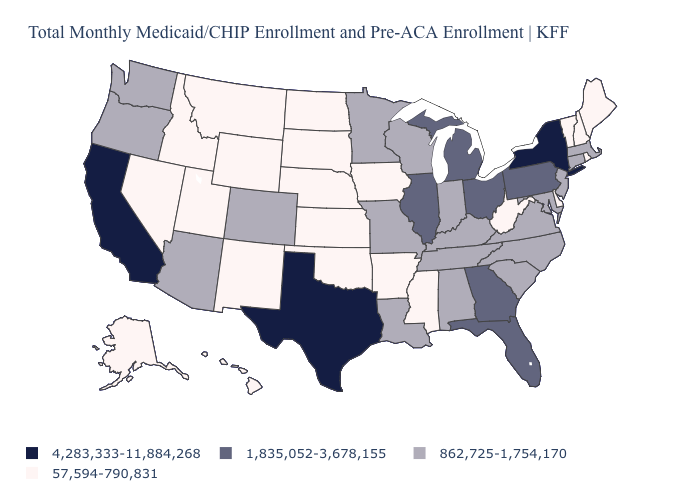Does Oregon have the lowest value in the USA?
Short answer required. No. What is the value of North Carolina?
Give a very brief answer. 862,725-1,754,170. What is the lowest value in states that border Maine?
Answer briefly. 57,594-790,831. What is the value of Nevada?
Answer briefly. 57,594-790,831. What is the lowest value in the USA?
Short answer required. 57,594-790,831. Name the states that have a value in the range 1,835,052-3,678,155?
Be succinct. Florida, Georgia, Illinois, Michigan, Ohio, Pennsylvania. What is the lowest value in the USA?
Be succinct. 57,594-790,831. Does the map have missing data?
Answer briefly. No. Among the states that border Virginia , does West Virginia have the lowest value?
Concise answer only. Yes. What is the value of Illinois?
Write a very short answer. 1,835,052-3,678,155. What is the value of Missouri?
Answer briefly. 862,725-1,754,170. Which states have the highest value in the USA?
Give a very brief answer. California, New York, Texas. Name the states that have a value in the range 1,835,052-3,678,155?
Short answer required. Florida, Georgia, Illinois, Michigan, Ohio, Pennsylvania. What is the value of California?
Quick response, please. 4,283,333-11,884,268. Does Iowa have a lower value than Hawaii?
Be succinct. No. 